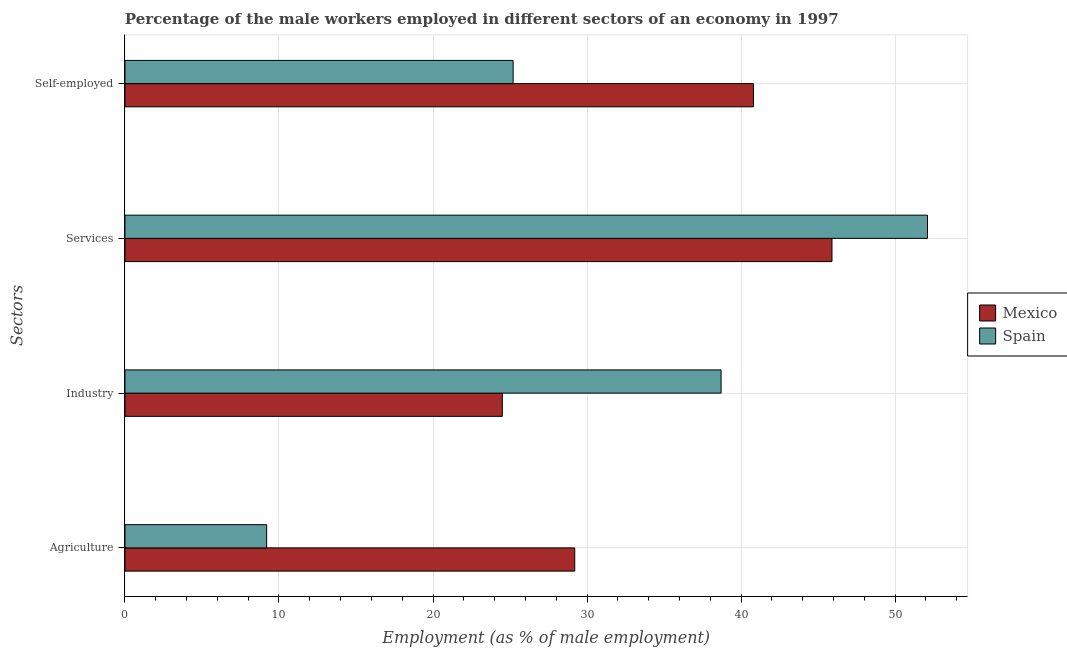How many different coloured bars are there?
Offer a terse response. 2. How many groups of bars are there?
Your answer should be very brief. 4. Are the number of bars on each tick of the Y-axis equal?
Give a very brief answer. Yes. How many bars are there on the 2nd tick from the top?
Ensure brevity in your answer.  2. What is the label of the 3rd group of bars from the top?
Your response must be concise. Industry. What is the percentage of male workers in services in Spain?
Your answer should be compact. 52.1. Across all countries, what is the maximum percentage of male workers in services?
Your response must be concise. 52.1. Across all countries, what is the minimum percentage of male workers in services?
Your response must be concise. 45.9. What is the difference between the percentage of male workers in agriculture in Spain and that in Mexico?
Provide a succinct answer. -20. What is the difference between the percentage of male workers in industry in Mexico and the percentage of male workers in services in Spain?
Your response must be concise. -27.6. What is the average percentage of male workers in agriculture per country?
Keep it short and to the point. 19.2. What is the difference between the percentage of male workers in services and percentage of self employed male workers in Mexico?
Your answer should be very brief. 5.1. In how many countries, is the percentage of male workers in services greater than 36 %?
Offer a very short reply. 2. What is the ratio of the percentage of male workers in agriculture in Mexico to that in Spain?
Ensure brevity in your answer.  3.17. Is the percentage of male workers in industry in Mexico less than that in Spain?
Ensure brevity in your answer.  Yes. What is the difference between the highest and the second highest percentage of male workers in industry?
Provide a short and direct response. 14.2. What is the difference between the highest and the lowest percentage of self employed male workers?
Your answer should be compact. 15.6. What does the 1st bar from the bottom in Agriculture represents?
Ensure brevity in your answer.  Mexico. Is it the case that in every country, the sum of the percentage of male workers in agriculture and percentage of male workers in industry is greater than the percentage of male workers in services?
Keep it short and to the point. No. Are the values on the major ticks of X-axis written in scientific E-notation?
Your response must be concise. No. Does the graph contain any zero values?
Keep it short and to the point. No. How many legend labels are there?
Provide a succinct answer. 2. What is the title of the graph?
Provide a succinct answer. Percentage of the male workers employed in different sectors of an economy in 1997. Does "Venezuela" appear as one of the legend labels in the graph?
Make the answer very short. No. What is the label or title of the X-axis?
Keep it short and to the point. Employment (as % of male employment). What is the label or title of the Y-axis?
Your answer should be compact. Sectors. What is the Employment (as % of male employment) of Mexico in Agriculture?
Offer a very short reply. 29.2. What is the Employment (as % of male employment) in Spain in Agriculture?
Your answer should be compact. 9.2. What is the Employment (as % of male employment) of Mexico in Industry?
Give a very brief answer. 24.5. What is the Employment (as % of male employment) in Spain in Industry?
Give a very brief answer. 38.7. What is the Employment (as % of male employment) of Mexico in Services?
Make the answer very short. 45.9. What is the Employment (as % of male employment) of Spain in Services?
Offer a very short reply. 52.1. What is the Employment (as % of male employment) in Mexico in Self-employed?
Your answer should be compact. 40.8. What is the Employment (as % of male employment) in Spain in Self-employed?
Make the answer very short. 25.2. Across all Sectors, what is the maximum Employment (as % of male employment) in Mexico?
Keep it short and to the point. 45.9. Across all Sectors, what is the maximum Employment (as % of male employment) of Spain?
Your answer should be very brief. 52.1. Across all Sectors, what is the minimum Employment (as % of male employment) of Spain?
Offer a very short reply. 9.2. What is the total Employment (as % of male employment) of Mexico in the graph?
Offer a very short reply. 140.4. What is the total Employment (as % of male employment) in Spain in the graph?
Offer a terse response. 125.2. What is the difference between the Employment (as % of male employment) of Mexico in Agriculture and that in Industry?
Make the answer very short. 4.7. What is the difference between the Employment (as % of male employment) of Spain in Agriculture and that in Industry?
Give a very brief answer. -29.5. What is the difference between the Employment (as % of male employment) of Mexico in Agriculture and that in Services?
Offer a terse response. -16.7. What is the difference between the Employment (as % of male employment) in Spain in Agriculture and that in Services?
Make the answer very short. -42.9. What is the difference between the Employment (as % of male employment) in Spain in Agriculture and that in Self-employed?
Your response must be concise. -16. What is the difference between the Employment (as % of male employment) in Mexico in Industry and that in Services?
Your response must be concise. -21.4. What is the difference between the Employment (as % of male employment) in Mexico in Industry and that in Self-employed?
Your answer should be very brief. -16.3. What is the difference between the Employment (as % of male employment) in Spain in Services and that in Self-employed?
Your answer should be compact. 26.9. What is the difference between the Employment (as % of male employment) of Mexico in Agriculture and the Employment (as % of male employment) of Spain in Industry?
Provide a short and direct response. -9.5. What is the difference between the Employment (as % of male employment) of Mexico in Agriculture and the Employment (as % of male employment) of Spain in Services?
Your answer should be compact. -22.9. What is the difference between the Employment (as % of male employment) in Mexico in Agriculture and the Employment (as % of male employment) in Spain in Self-employed?
Offer a terse response. 4. What is the difference between the Employment (as % of male employment) of Mexico in Industry and the Employment (as % of male employment) of Spain in Services?
Your answer should be very brief. -27.6. What is the difference between the Employment (as % of male employment) of Mexico in Services and the Employment (as % of male employment) of Spain in Self-employed?
Your answer should be very brief. 20.7. What is the average Employment (as % of male employment) of Mexico per Sectors?
Keep it short and to the point. 35.1. What is the average Employment (as % of male employment) of Spain per Sectors?
Provide a succinct answer. 31.3. What is the difference between the Employment (as % of male employment) in Mexico and Employment (as % of male employment) in Spain in Self-employed?
Your response must be concise. 15.6. What is the ratio of the Employment (as % of male employment) of Mexico in Agriculture to that in Industry?
Ensure brevity in your answer.  1.19. What is the ratio of the Employment (as % of male employment) of Spain in Agriculture to that in Industry?
Provide a succinct answer. 0.24. What is the ratio of the Employment (as % of male employment) in Mexico in Agriculture to that in Services?
Give a very brief answer. 0.64. What is the ratio of the Employment (as % of male employment) in Spain in Agriculture to that in Services?
Offer a very short reply. 0.18. What is the ratio of the Employment (as % of male employment) in Mexico in Agriculture to that in Self-employed?
Provide a short and direct response. 0.72. What is the ratio of the Employment (as % of male employment) in Spain in Agriculture to that in Self-employed?
Keep it short and to the point. 0.37. What is the ratio of the Employment (as % of male employment) in Mexico in Industry to that in Services?
Provide a succinct answer. 0.53. What is the ratio of the Employment (as % of male employment) in Spain in Industry to that in Services?
Your answer should be compact. 0.74. What is the ratio of the Employment (as % of male employment) in Mexico in Industry to that in Self-employed?
Offer a terse response. 0.6. What is the ratio of the Employment (as % of male employment) of Spain in Industry to that in Self-employed?
Offer a very short reply. 1.54. What is the ratio of the Employment (as % of male employment) of Mexico in Services to that in Self-employed?
Your response must be concise. 1.12. What is the ratio of the Employment (as % of male employment) in Spain in Services to that in Self-employed?
Your response must be concise. 2.07. What is the difference between the highest and the second highest Employment (as % of male employment) in Spain?
Give a very brief answer. 13.4. What is the difference between the highest and the lowest Employment (as % of male employment) of Mexico?
Make the answer very short. 21.4. What is the difference between the highest and the lowest Employment (as % of male employment) of Spain?
Offer a very short reply. 42.9. 